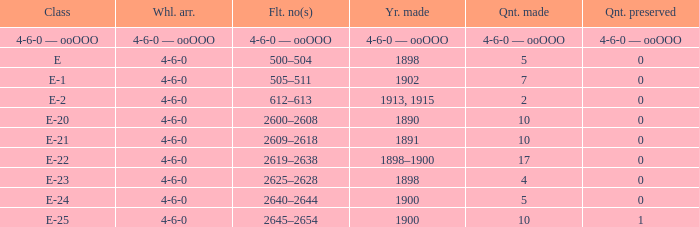What is the quantity made of the e-22 class, which has a quantity preserved of 0? 17.0. 